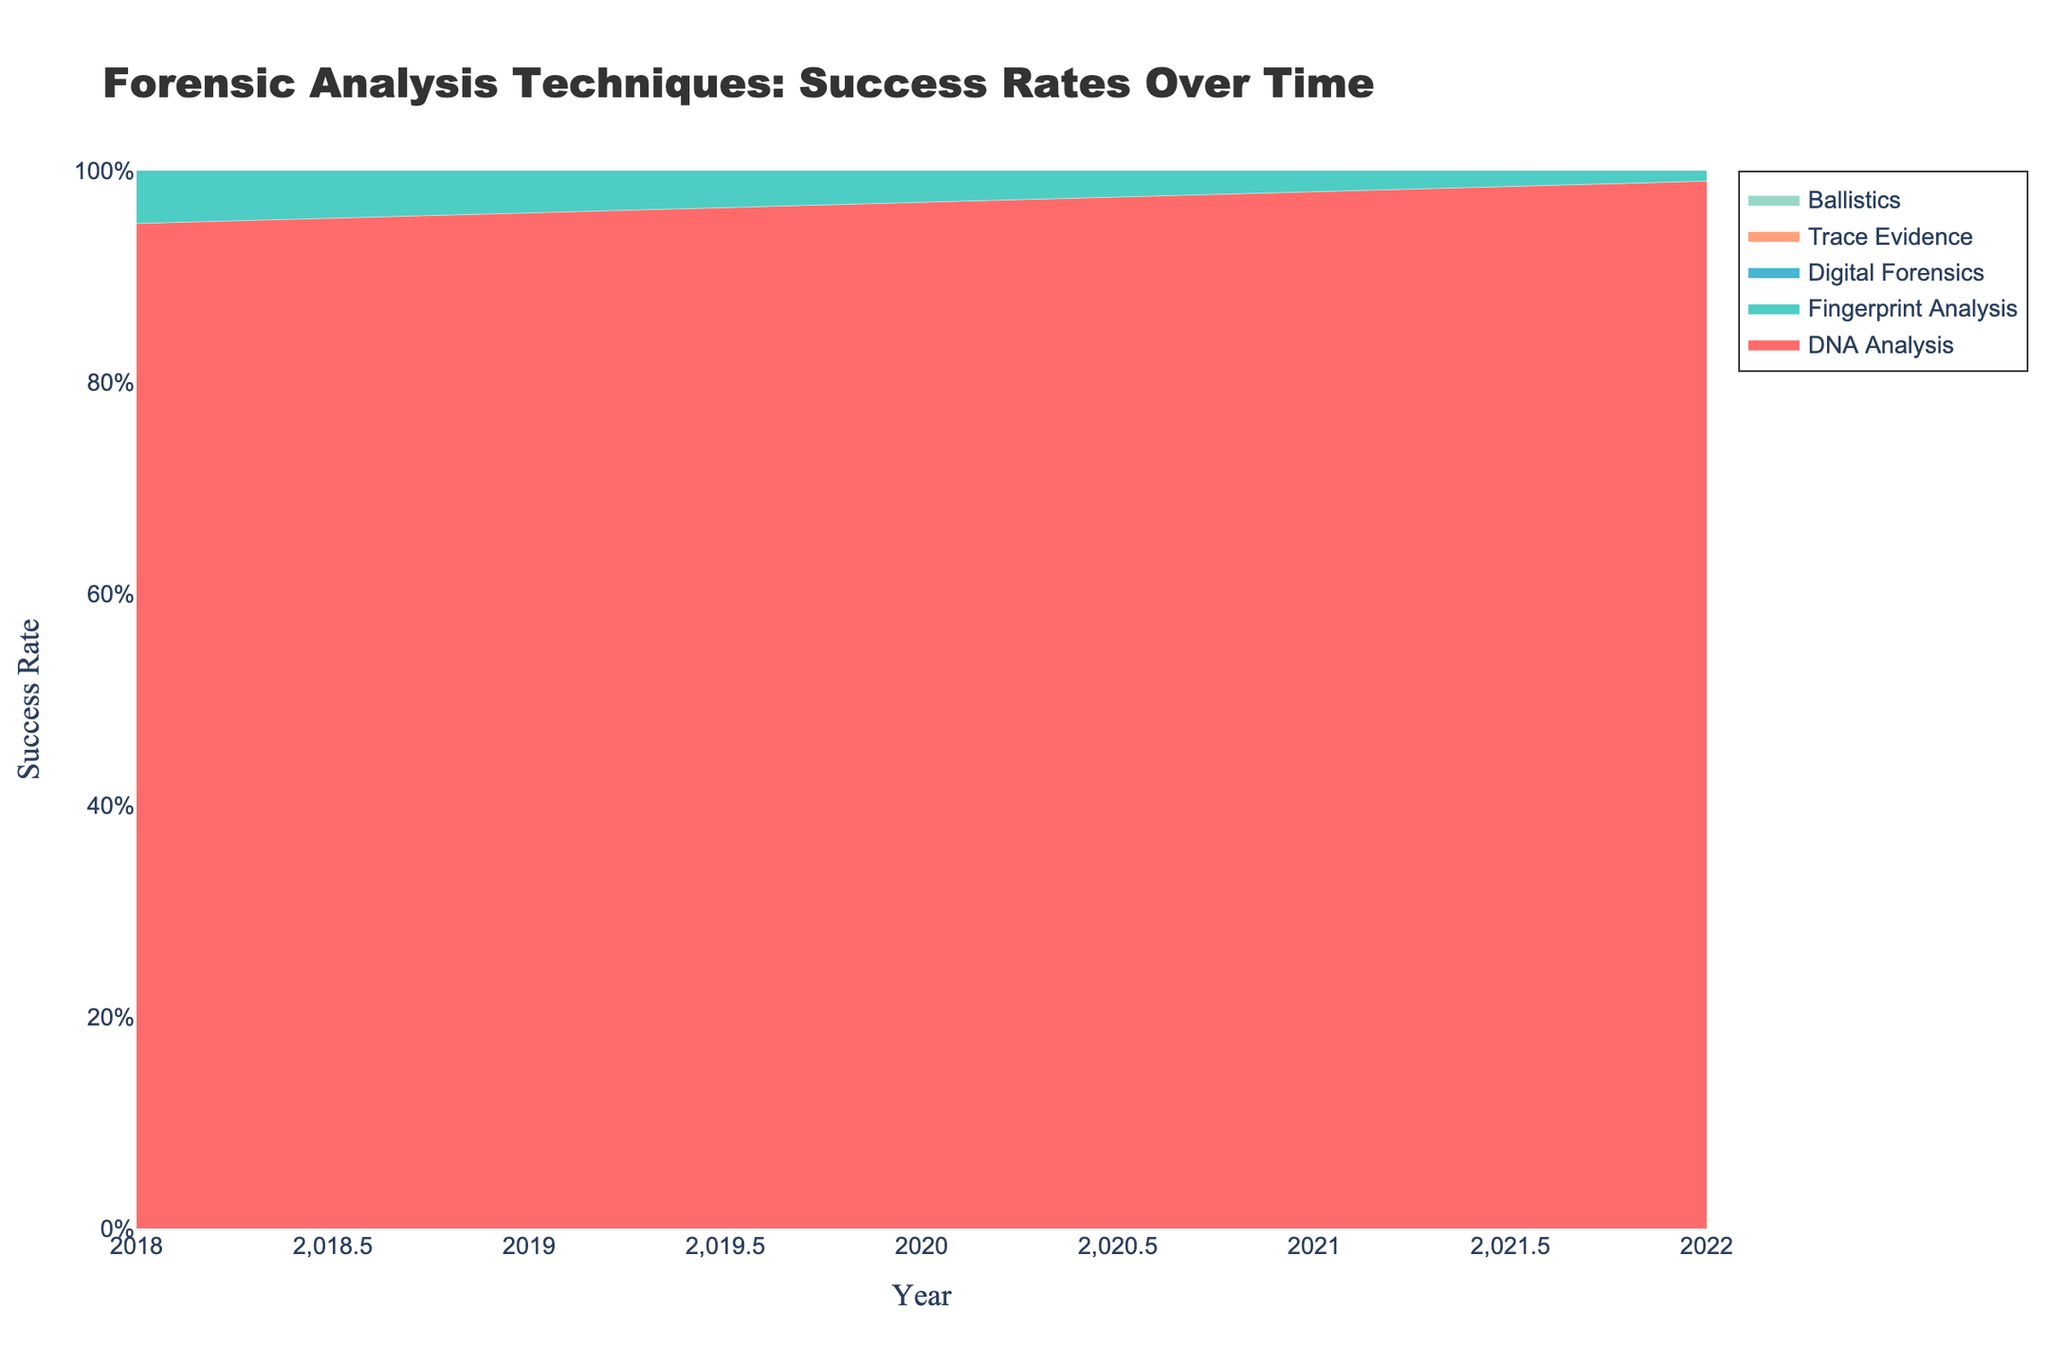what is the title of the plot? The title of the plot is usually displayed at the top of the graph. In this case, it reads "Forensic Analysis Techniques: Success Rates Over Time," which conveys the subject of the visualization.
Answer: Forensic Analysis Techniques: Success Rates Over Time what is the success rate of DNA Analysis in 2020? To find the success rate of DNA Analysis in 2020, look for the value on the y-axis corresponding to the year 2020 on the x-axis for the DNA Analysis trace (which may be color-coded). The exact rate is visually marked on the graph.
Answer: 0.97 which technique had the lowest success rate in 2022? By examining the graph for the year 2022, compare the success rates of all techniques. The line associated with Ballistics is the lowest on the y-axis for that year.
Answer: Ballistics how did the success rate of Fingerprint Analysis change from 2018 to 2022? Locate the Fingerprint Analysis trace and looks at the data points for 2018 and 2022. Subtract the 2018 value from the 2022 value to denote change. (0.91 - 0.88 = 0.03)
Answer: Increased by 0.03 which two techniques showed the closest success rates in 2021? Assess the success rates for all techniques in 2021. Ballistics (0.74) and Trace Evidence (0.79) are closest in value.
Answer: Ballistics and Trace Evidence whats the overall trend for success rates of Digital Forensics from 2018 to 2022? Trace the Digital Forensics line from 2018 to 2022. The trend shows a gradually increasing success rate.
Answer: Increasing trend what is the difference in success rates between Digital Forensics and Trace Evidence in 2019? Check the y-values for Digital Forensics and Trace Evidence in 2019. Subtract the success rate of Trace Evidence from that of Digital Forensics (0.84 - 0.74 = 0.10)
Answer: 0.10 what is the average success rate of DNA Analysis over the 5 years? Add the yearly success rates for DNA Analysis (0.95, 0.96, 0.97, 0.98, 0.99) and divide by 5: (0.95+0.96+0.97+0.98+0.99)/5 = 0.97
Answer: 0.97 which year showed the highest success rate for Ballistics? Review the y-values for Ballistics from 2018 to 2022. The highest observed rate occurs in 2022 at 0.75.
Answer: 2022 